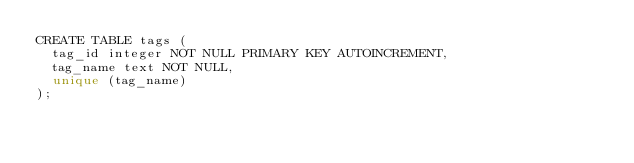Convert code to text. <code><loc_0><loc_0><loc_500><loc_500><_SQL_>CREATE TABLE tags (
  tag_id integer NOT NULL PRIMARY KEY AUTOINCREMENT,
  tag_name text NOT NULL,
  unique (tag_name)
);</code> 